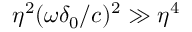Convert formula to latex. <formula><loc_0><loc_0><loc_500><loc_500>\eta ^ { 2 } ( \omega \delta _ { 0 } / c ) ^ { 2 } \gg \eta ^ { 4 }</formula> 